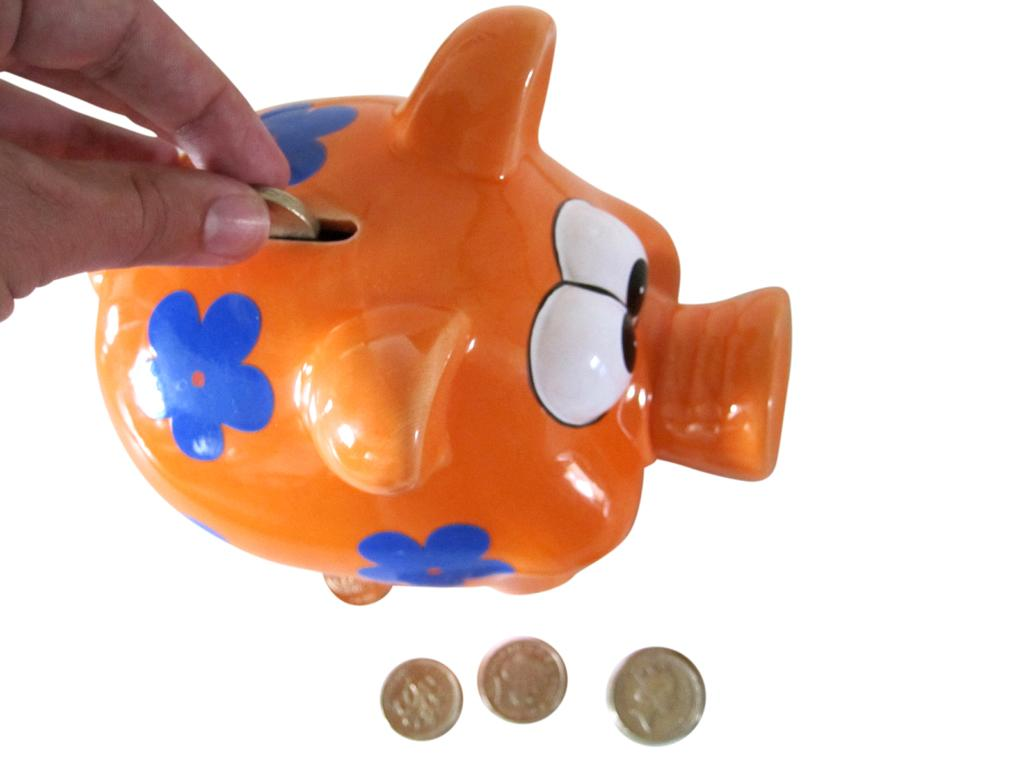What object is the main focus of the image? There is a piggy bank in the image. What is the person's hand doing with the piggy bank? A person's hand is putting coins into the piggy bank. Are there any coins visible in the image besides those being placed in the piggy bank? Yes, there are coins besides the piggy bank. What type of kite is being flown in the image? There is no kite present in the image; it features a piggy bank and coins. 